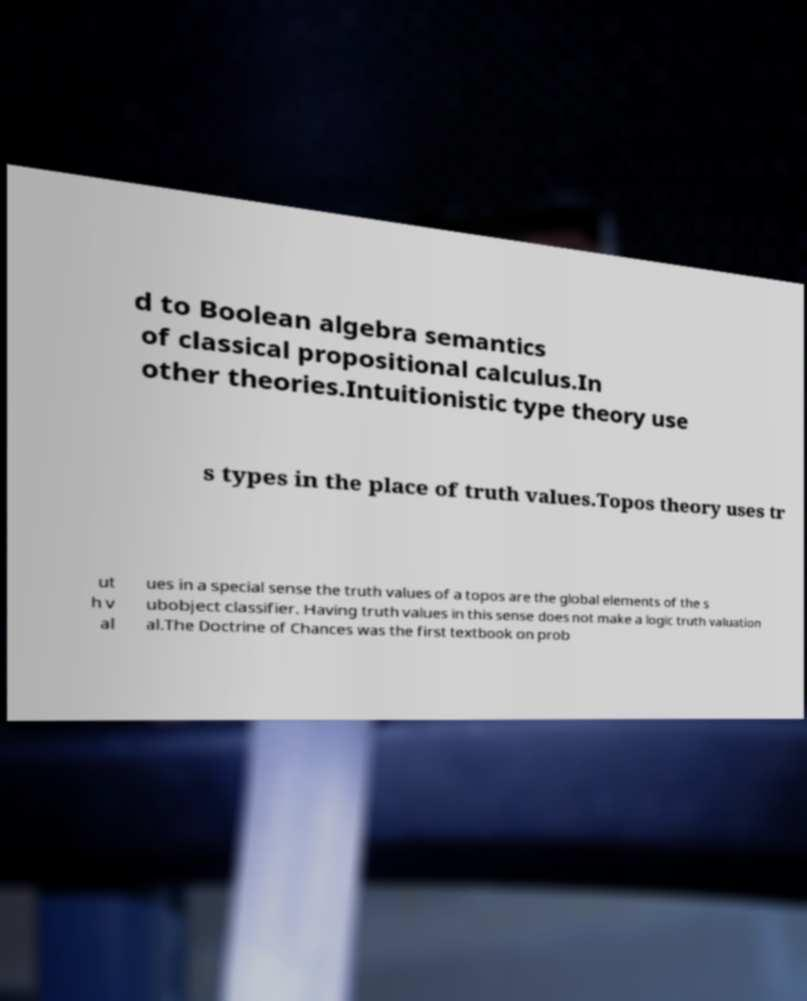What messages or text are displayed in this image? I need them in a readable, typed format. d to Boolean algebra semantics of classical propositional calculus.In other theories.Intuitionistic type theory use s types in the place of truth values.Topos theory uses tr ut h v al ues in a special sense the truth values of a topos are the global elements of the s ubobject classifier. Having truth values in this sense does not make a logic truth valuation al.The Doctrine of Chances was the first textbook on prob 